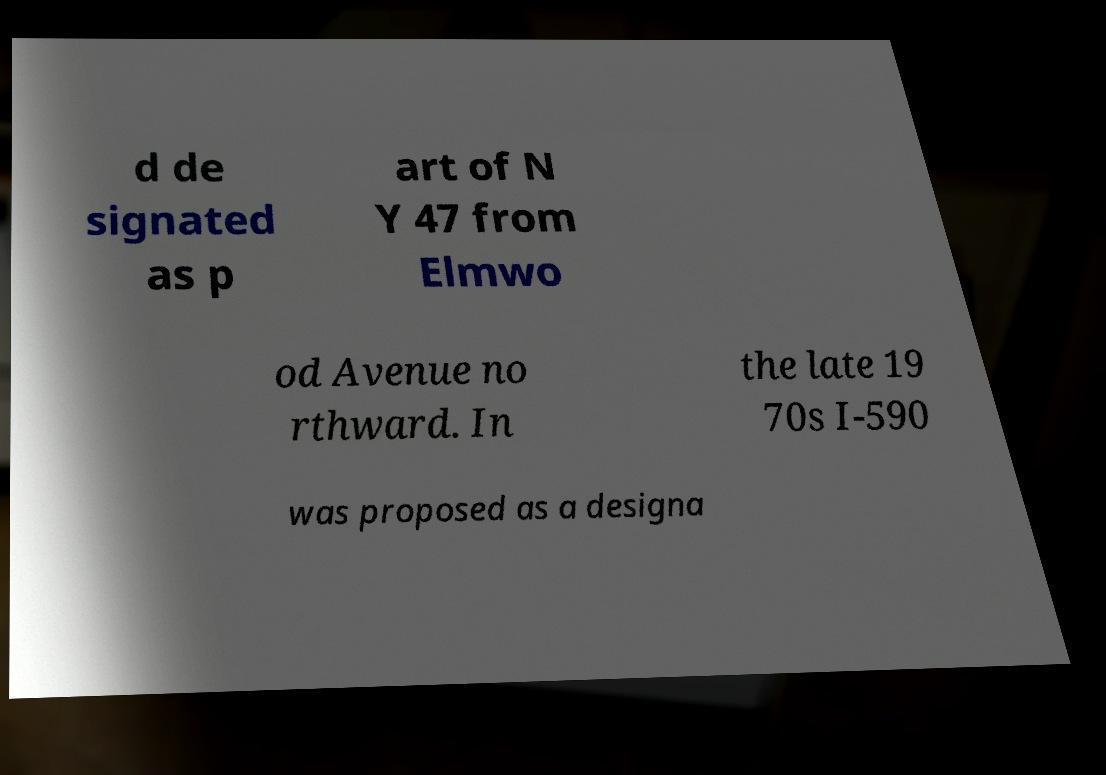What messages or text are displayed in this image? I need them in a readable, typed format. d de signated as p art of N Y 47 from Elmwo od Avenue no rthward. In the late 19 70s I-590 was proposed as a designa 